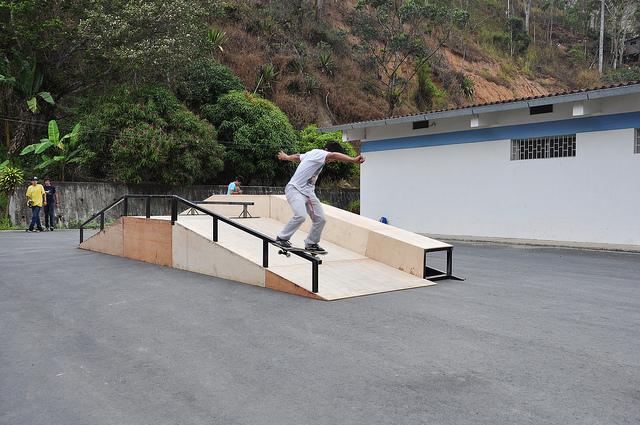What is the ramp made of?
Quick response, please. Wood. What is he riding on?
Give a very brief answer. Skateboard. Is the person at the forefront wearing athletic clothes?
Give a very brief answer. Yes. 